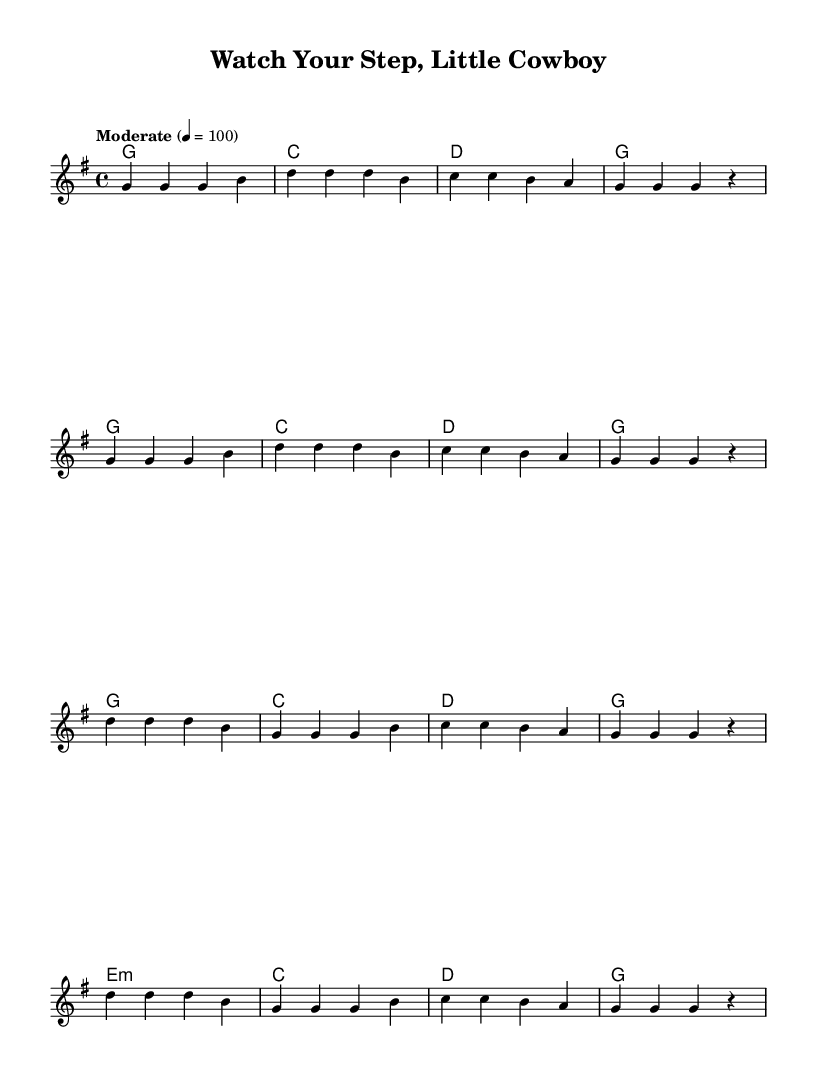What is the key signature of this music? The key signature is indicated by the two sharps at the beginning of the staff, which confirms that the piece is in G major.
Answer: G major What is the time signature of this music? The time signature is shown as a 4/4, which is represented by the two numbers appearing next to each other at the beginning of the score. This indicates four beats per measure.
Answer: 4/4 What is the tempo marking of this piece? The tempo marking is noted as "Moderate" with a metronome marking of 100, which tells you the speed of the piece is moderate at this specified beat.
Answer: Moderate 4 = 100 How many measures are in the verse section? By counting the measures in the verses, we see there are 8 measures in total since each line has 4 measures and there are 2 lines in the verse.
Answer: 8 What type of chord is in the chorus's last line? The last line of the chorus contains an e minor chord, which is typically noted as "e:m" in standard chord notation within the score.
Answer: e:m What is the primary theme of the lyrics? The primary theme focuses on childhood safety as depicted in the lyrics, emphasizing the importance of being alert and listening to parents for safety guidance.
Answer: Childhood safety 